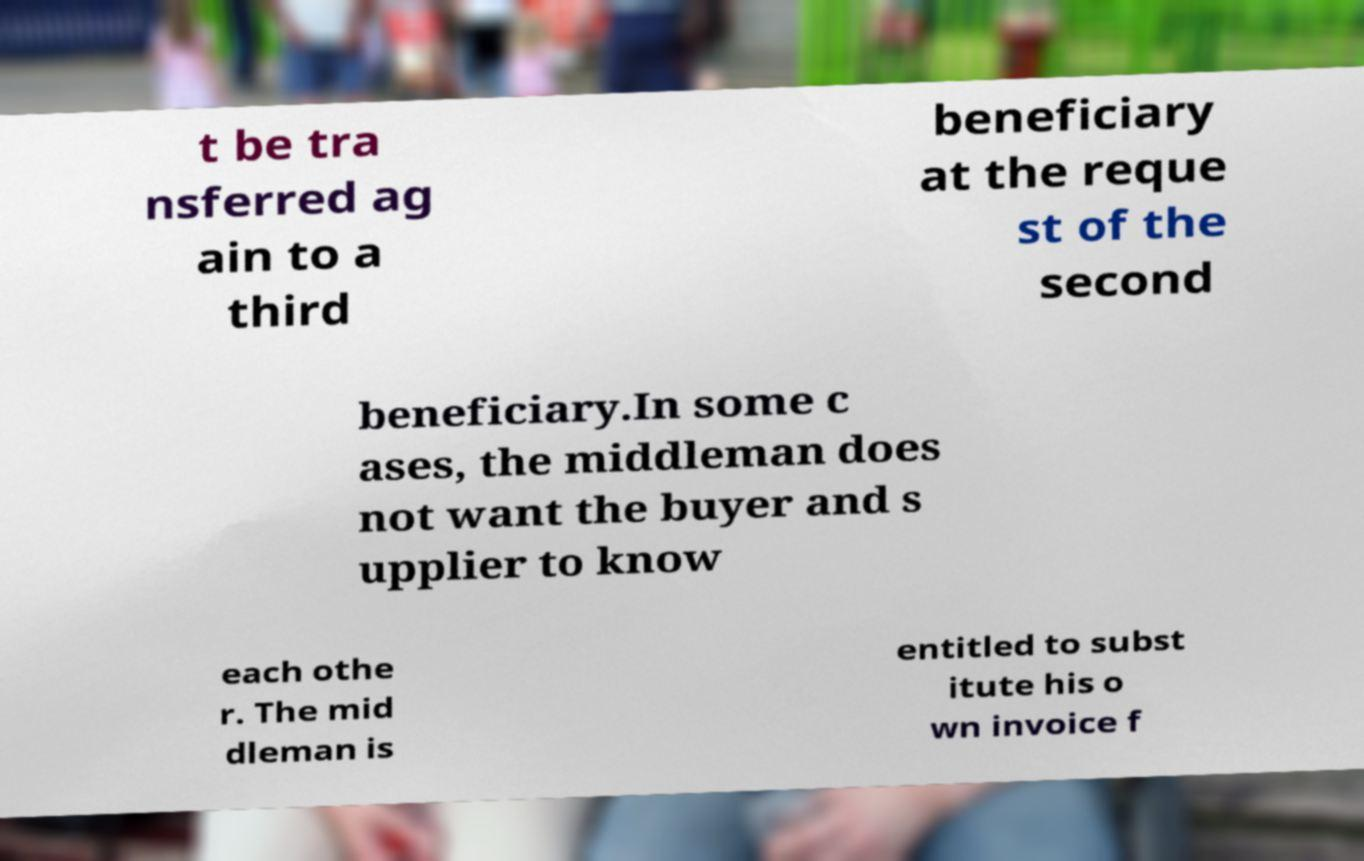I need the written content from this picture converted into text. Can you do that? t be tra nsferred ag ain to a third beneficiary at the reque st of the second beneficiary.In some c ases, the middleman does not want the buyer and s upplier to know each othe r. The mid dleman is entitled to subst itute his o wn invoice f 